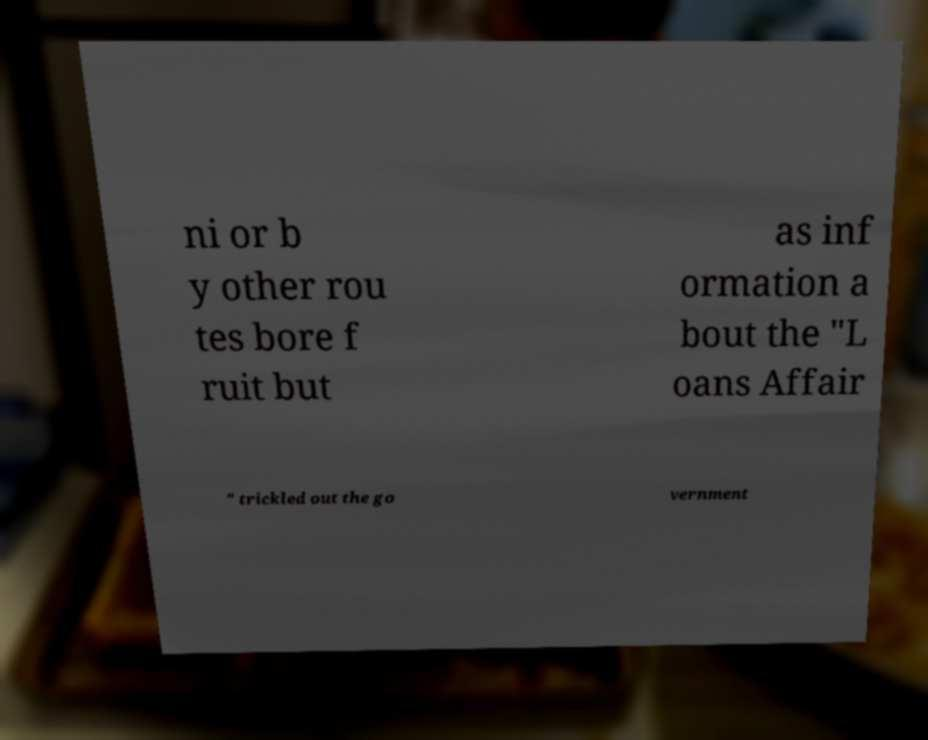For documentation purposes, I need the text within this image transcribed. Could you provide that? ni or b y other rou tes bore f ruit but as inf ormation a bout the "L oans Affair " trickled out the go vernment 